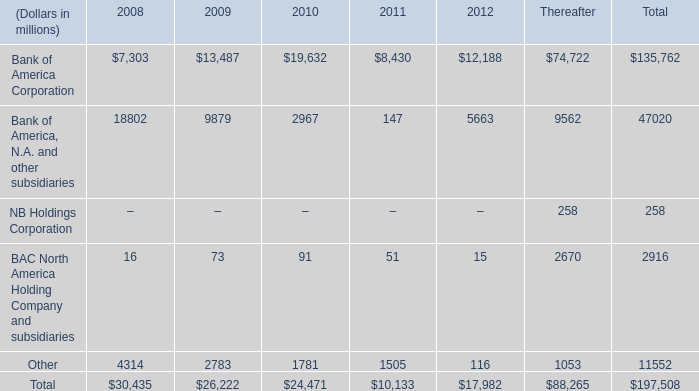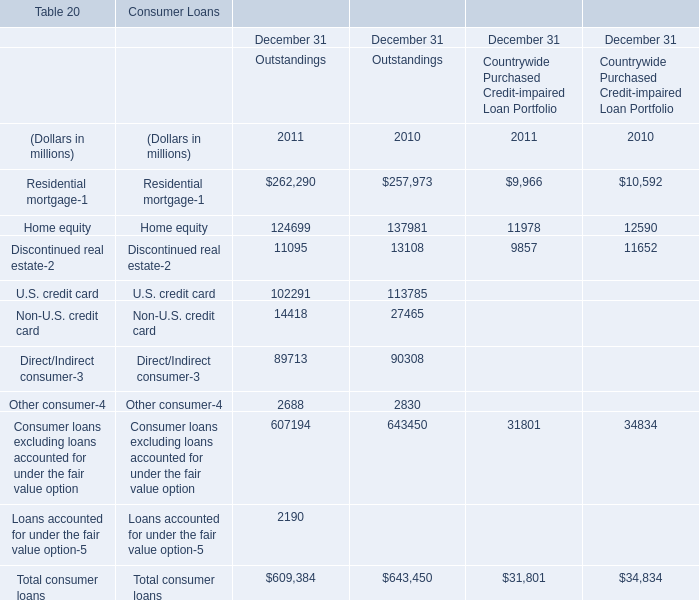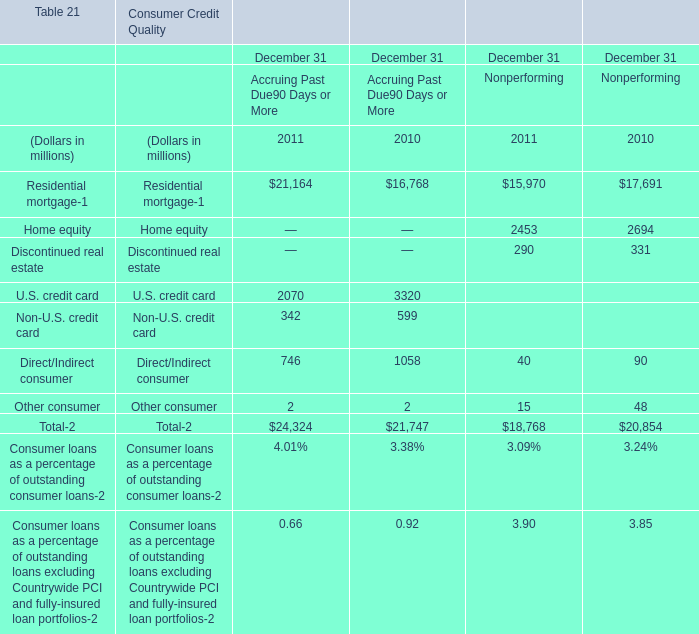What is the total amount of Home equity of Consumer Credit Quality December 31 Nonperforming 2010, and U.S. credit card of Consumer Loans December 31 Outstandings 2010 ? 
Computations: (2694.0 + 113785.0)
Answer: 116479.0. 